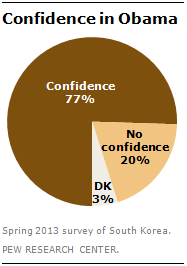Specify some key components in this picture. Light orange in a pie graph typically represents a value of 20%. 